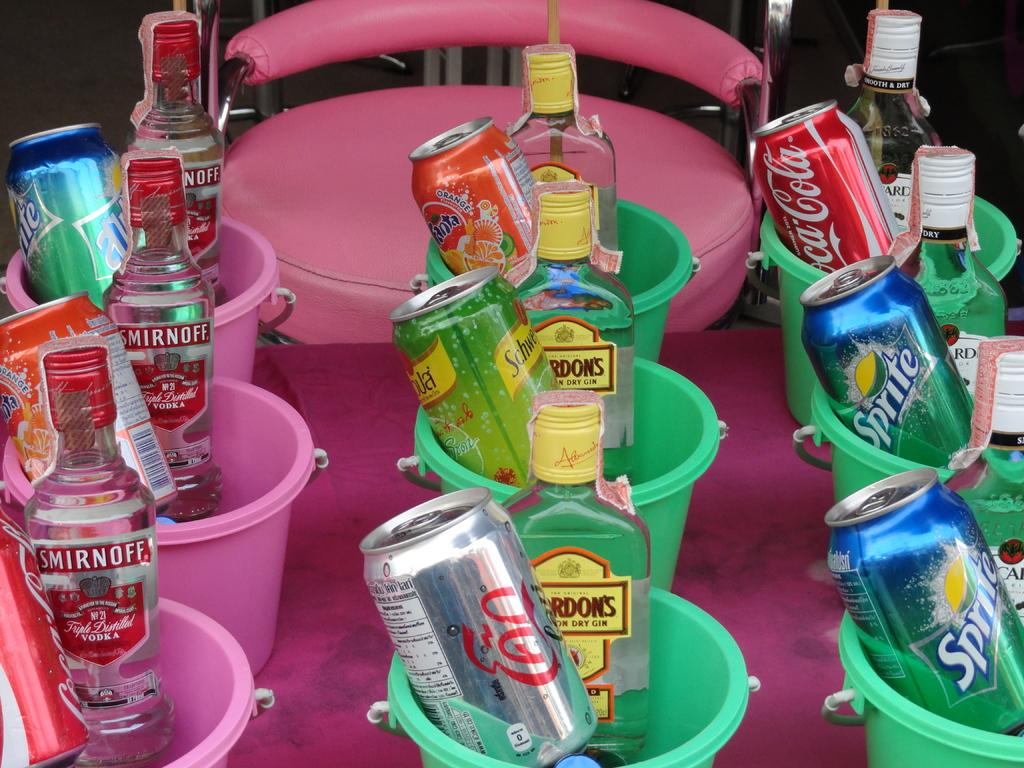What is located in the foreground of the picture? There is a table in the foreground of the picture. What objects are on the table? There are mugs on the table. What is inside the mugs? There are vodka bottles in some mugs and soft drinks in others. What can be seen in the background of the image? There is a chair in the background of the image. What type of toys are scattered around the table in the image? There are no toys present in the image; it features a table with mugs containing vodka bottles and soft drinks. 